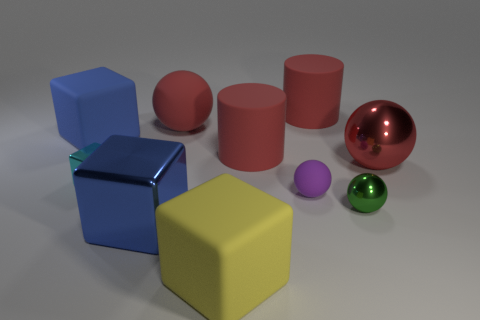Is there anything else that has the same shape as the blue matte thing? Yes, the yellow object shares the same cubic shape as the blue matte cube. Both objects are cubes characterized by equal-length edges and right angles between their faces. 